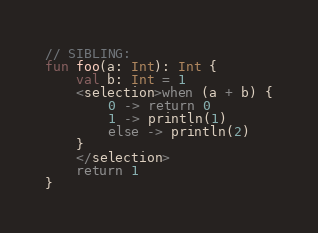<code> <loc_0><loc_0><loc_500><loc_500><_Kotlin_>// SIBLING:
fun foo(a: Int): Int {
    val b: Int = 1
    <selection>when (a + b) {
        0 -> return 0
        1 -> println(1)
        else -> println(2)
    }
    </selection>
    return 1
}</code> 